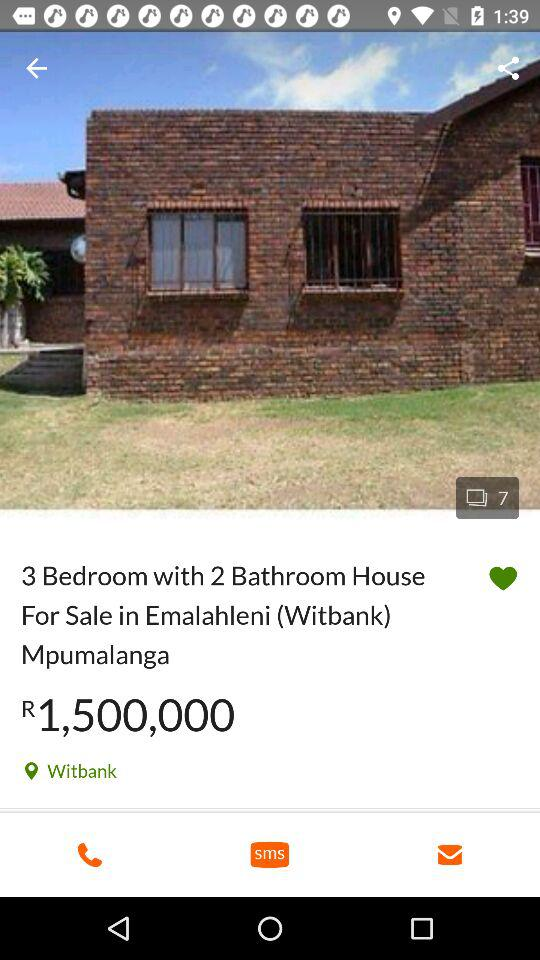How much is the price of the house?
Answer the question using a single word or phrase. R 1,500,000 